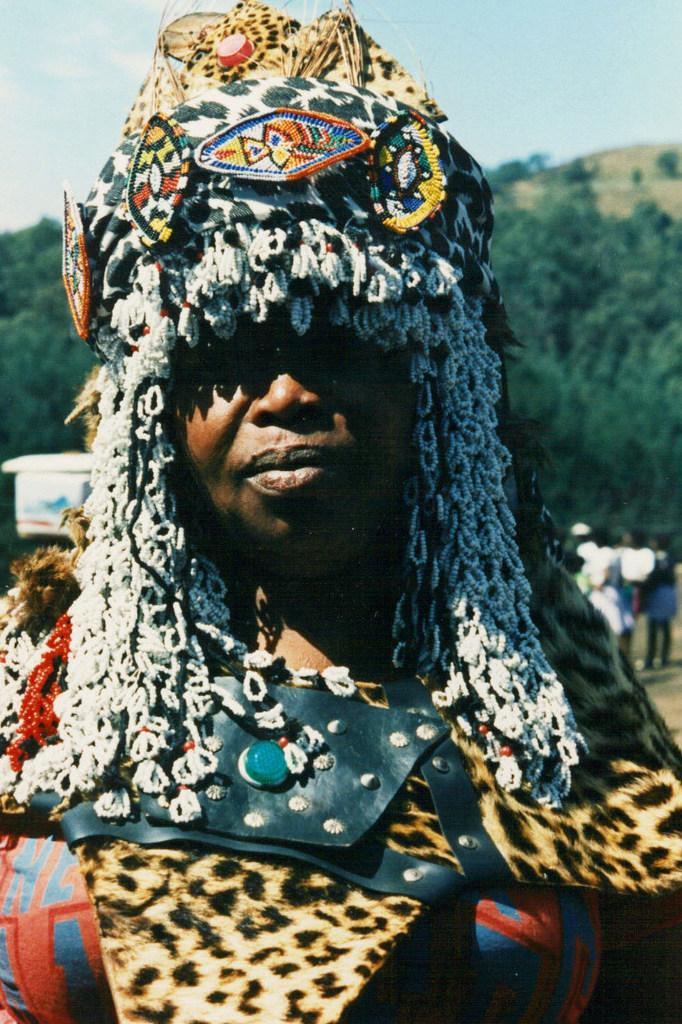Who is the main subject in the image? There is a woman in the image. What is the woman wearing? The woman is wearing a costume. What can be seen in the background of the image? There are people, trees, the sky, and objects in the background of the image. How many fingers can be seen on the woman's hand in the image? The image does not show the woman's hand, so it is not possible to determine the number of fingers. 